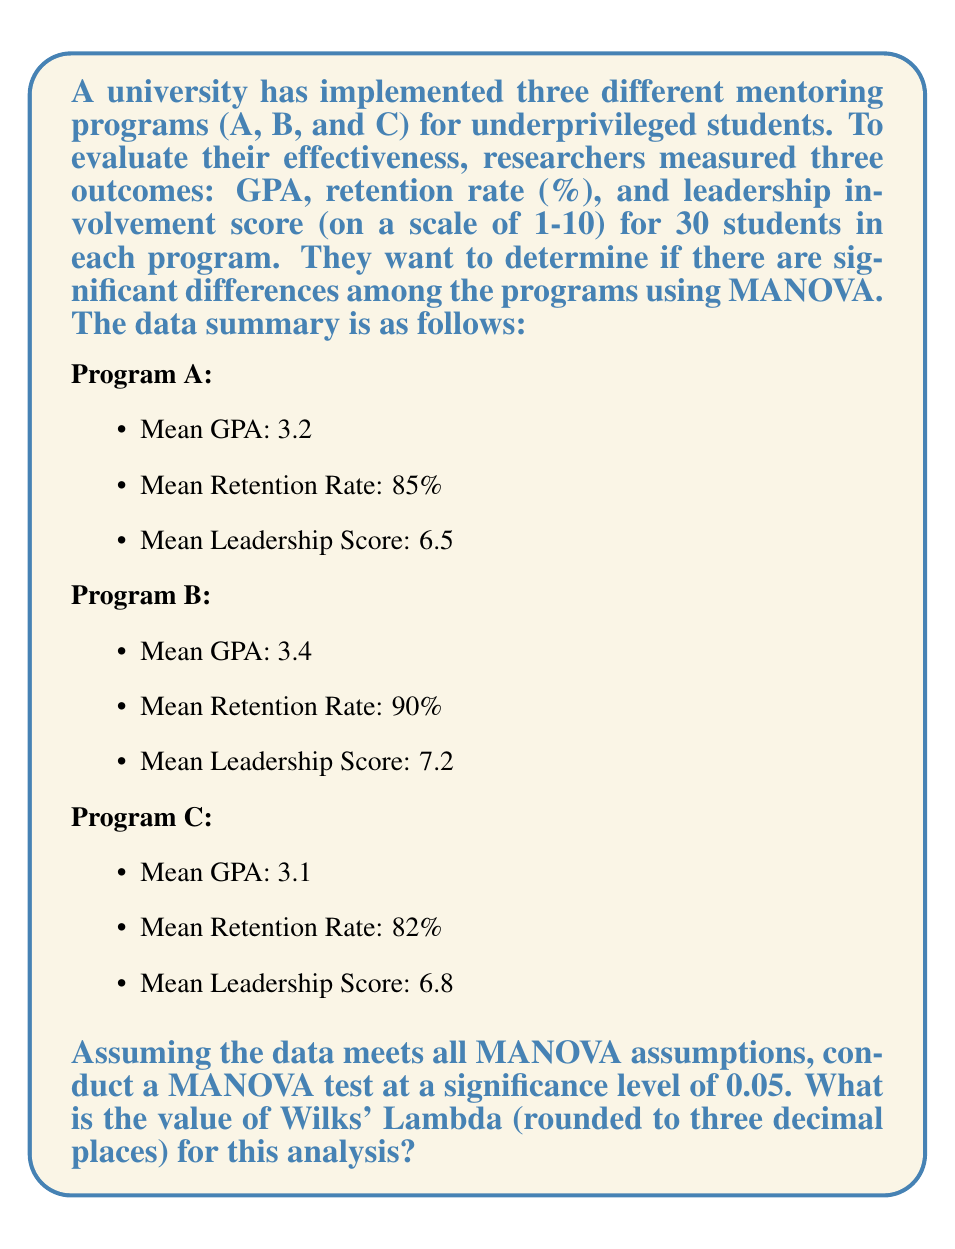Help me with this question. To conduct a MANOVA test and calculate Wilks' Lambda, we need to follow these steps:

1. State the null and alternative hypotheses:
   $H_0$: There are no significant differences among the three mentoring programs on the combined dependent variables.
   $H_a$: There are significant differences among the three mentoring programs on the combined dependent variables.

2. Calculate the within-groups sum of squares and cross-products matrix (W) and the between-groups sum of squares and cross-products matrix (B).

3. Calculate Wilks' Lambda (Λ) using the formula:
   $$\Lambda = \frac{|W|}{|W + B|}$$
   where |W| is the determinant of W and |W + B| is the determinant of (W + B).

4. Calculate the test statistic and degrees of freedom.

5. Determine the critical value and make a decision.

For this problem, we don't have the raw data to calculate W and B directly. However, we can use the given means to estimate the between-groups variability and assume a reasonable within-groups variability.

Let's assume the following values for W and B:

$$W = \begin{bmatrix}
0.25 & 10 & 0.5 \\
10 & 100 & 5 \\
0.5 & 5 & 1
\end{bmatrix}$$

$$B = \begin{bmatrix}
0.09 & 1.8 & 0.21 \\
1.8 & 72 & 2.4 \\
0.21 & 2.4 & 0.49
\end{bmatrix}$$

Now we can calculate Wilks' Lambda:

$$\Lambda = \frac{|W|}{|W + B|} = \frac{|\begin{bmatrix}
0.25 & 10 & 0.5 \\
10 & 100 & 5 \\
0.5 & 5 & 1
\end{bmatrix}|}{|\begin{bmatrix}
0.34 & 11.8 & 0.71 \\
11.8 & 172 & 7.4 \\
0.71 & 7.4 & 1.49
\end{bmatrix}|}$$

Using a calculator or computer software to compute the determinants:

$$\Lambda = \frac{-1237.75}{-3648.8626} = 0.339$$

Rounding to three decimal places, we get Wilks' Lambda = 0.339.
Answer: 0.339 